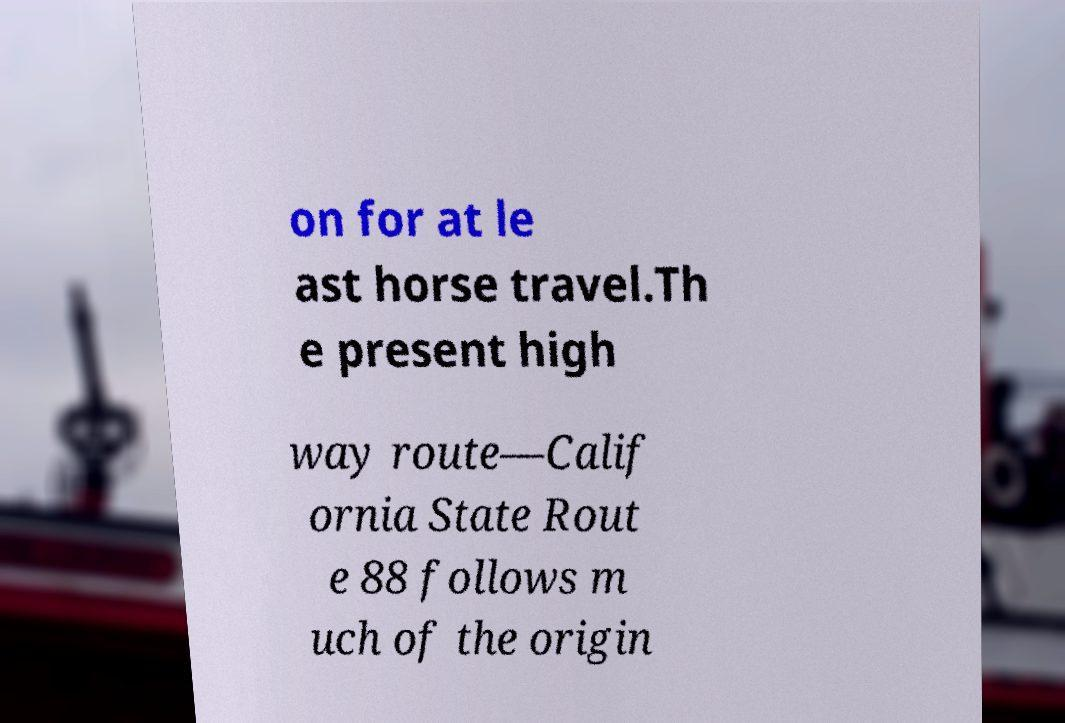Can you read and provide the text displayed in the image?This photo seems to have some interesting text. Can you extract and type it out for me? on for at le ast horse travel.Th e present high way route—Calif ornia State Rout e 88 follows m uch of the origin 